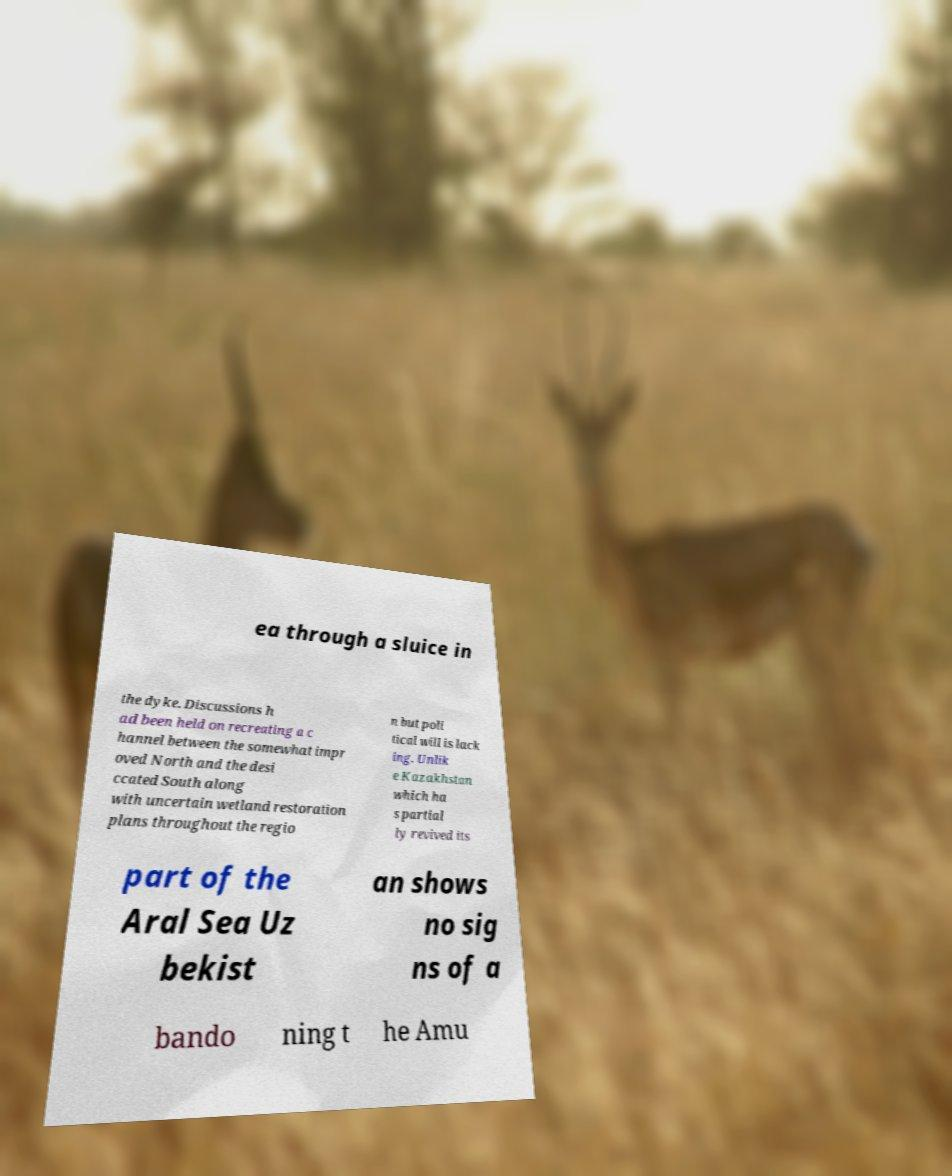Can you read and provide the text displayed in the image?This photo seems to have some interesting text. Can you extract and type it out for me? ea through a sluice in the dyke. Discussions h ad been held on recreating a c hannel between the somewhat impr oved North and the desi ccated South along with uncertain wetland restoration plans throughout the regio n but poli tical will is lack ing. Unlik e Kazakhstan which ha s partial ly revived its part of the Aral Sea Uz bekist an shows no sig ns of a bando ning t he Amu 